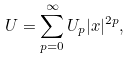Convert formula to latex. <formula><loc_0><loc_0><loc_500><loc_500>U = \sum ^ { \infty } _ { p = 0 } U _ { p } | x | ^ { 2 p } ,</formula> 